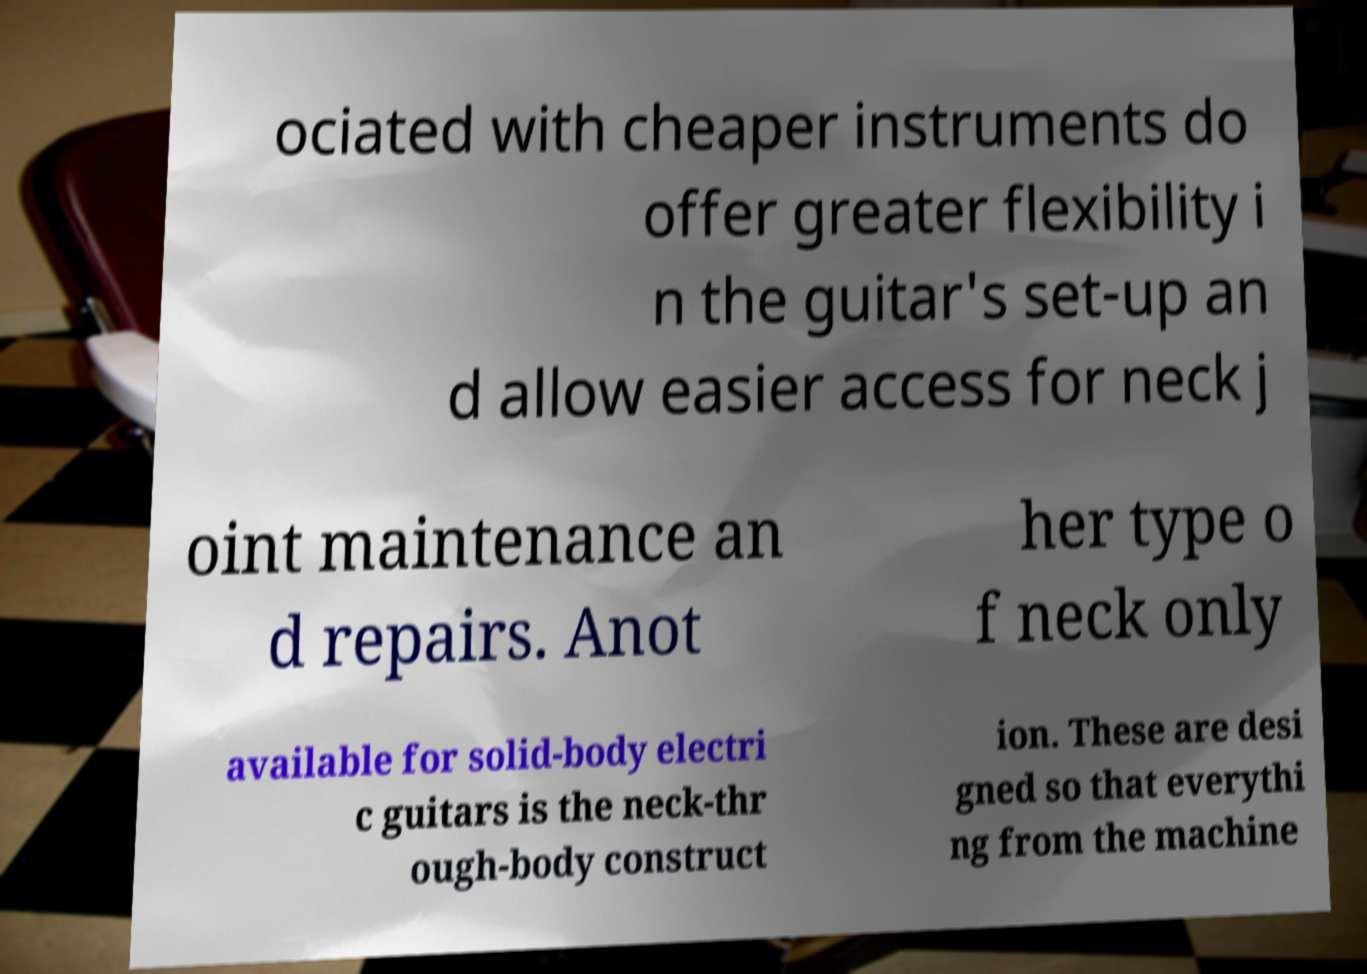What messages or text are displayed in this image? I need them in a readable, typed format. ociated with cheaper instruments do offer greater flexibility i n the guitar's set-up an d allow easier access for neck j oint maintenance an d repairs. Anot her type o f neck only available for solid-body electri c guitars is the neck-thr ough-body construct ion. These are desi gned so that everythi ng from the machine 